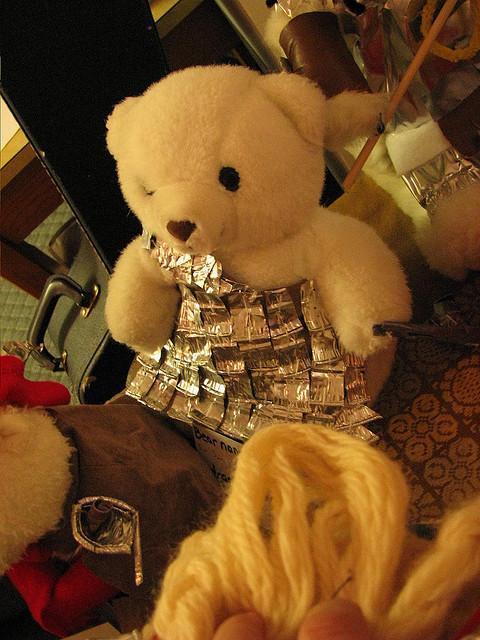How many people are visible in this photo?
Give a very brief answer. 0. 